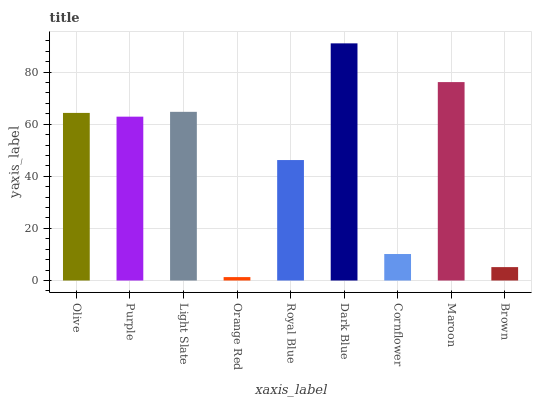Is Orange Red the minimum?
Answer yes or no. Yes. Is Dark Blue the maximum?
Answer yes or no. Yes. Is Purple the minimum?
Answer yes or no. No. Is Purple the maximum?
Answer yes or no. No. Is Olive greater than Purple?
Answer yes or no. Yes. Is Purple less than Olive?
Answer yes or no. Yes. Is Purple greater than Olive?
Answer yes or no. No. Is Olive less than Purple?
Answer yes or no. No. Is Purple the high median?
Answer yes or no. Yes. Is Purple the low median?
Answer yes or no. Yes. Is Light Slate the high median?
Answer yes or no. No. Is Brown the low median?
Answer yes or no. No. 